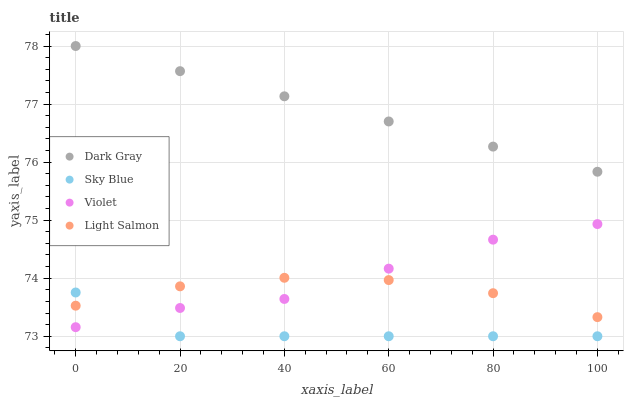Does Sky Blue have the minimum area under the curve?
Answer yes or no. Yes. Does Dark Gray have the maximum area under the curve?
Answer yes or no. Yes. Does Light Salmon have the minimum area under the curve?
Answer yes or no. No. Does Light Salmon have the maximum area under the curve?
Answer yes or no. No. Is Dark Gray the smoothest?
Answer yes or no. Yes. Is Violet the roughest?
Answer yes or no. Yes. Is Sky Blue the smoothest?
Answer yes or no. No. Is Sky Blue the roughest?
Answer yes or no. No. Does Sky Blue have the lowest value?
Answer yes or no. Yes. Does Light Salmon have the lowest value?
Answer yes or no. No. Does Dark Gray have the highest value?
Answer yes or no. Yes. Does Light Salmon have the highest value?
Answer yes or no. No. Is Light Salmon less than Dark Gray?
Answer yes or no. Yes. Is Dark Gray greater than Violet?
Answer yes or no. Yes. Does Sky Blue intersect Light Salmon?
Answer yes or no. Yes. Is Sky Blue less than Light Salmon?
Answer yes or no. No. Is Sky Blue greater than Light Salmon?
Answer yes or no. No. Does Light Salmon intersect Dark Gray?
Answer yes or no. No. 